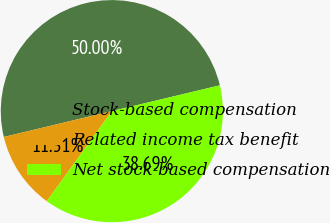Convert chart. <chart><loc_0><loc_0><loc_500><loc_500><pie_chart><fcel>Stock-based compensation<fcel>Related income tax benefit<fcel>Net stock-based compensation<nl><fcel>50.0%<fcel>11.31%<fcel>38.69%<nl></chart> 